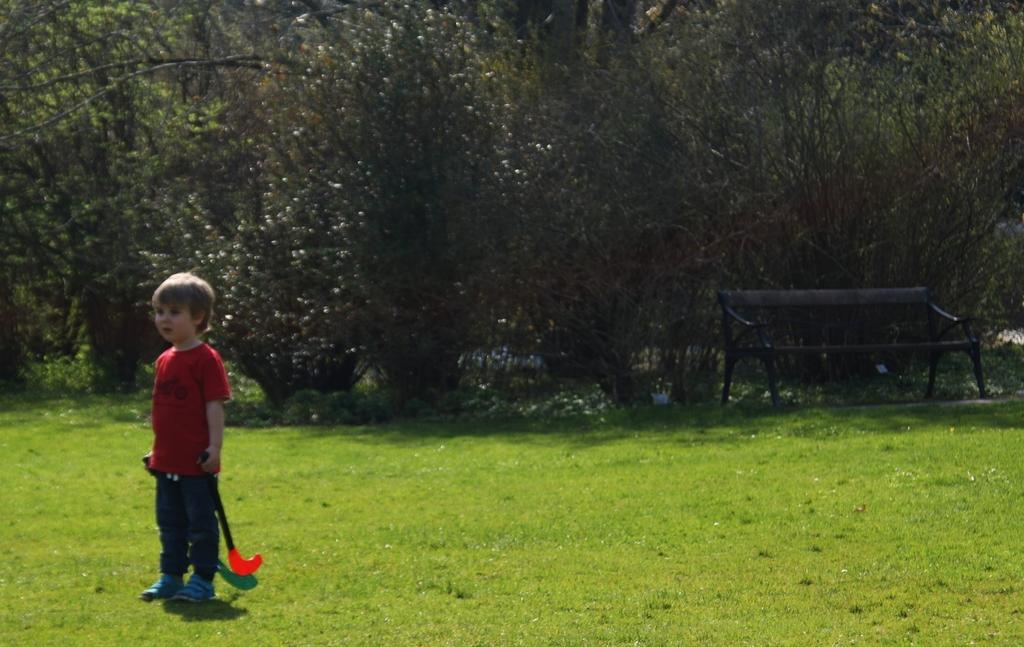Describe this image in one or two sentences. In this picture the kid is standing on the floor with objects in his both the hands. The image is taken outside in the grassland or a park. There are trees in the background and a black color chair. 